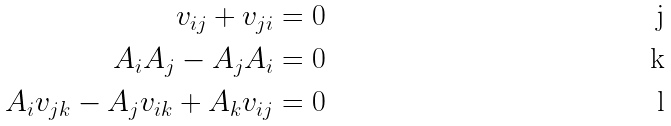Convert formula to latex. <formula><loc_0><loc_0><loc_500><loc_500>v _ { i j } + v _ { j i } & = 0 \\ A _ { i } A _ { j } - A _ { j } A _ { i } & = 0 \\ A _ { i } v _ { j k } - A _ { j } v _ { i k } + A _ { k } v _ { i j } & = 0</formula> 